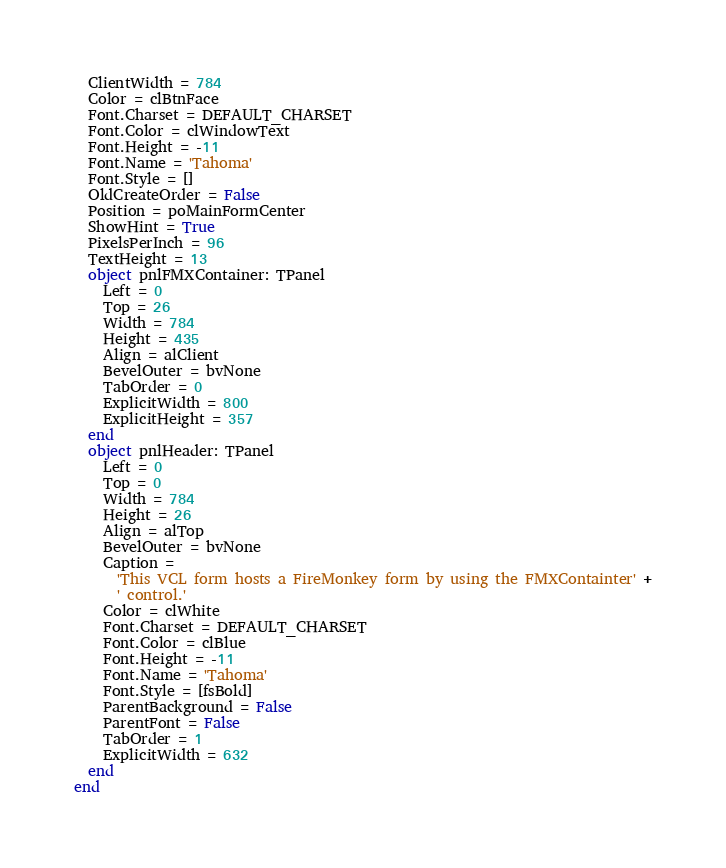<code> <loc_0><loc_0><loc_500><loc_500><_Pascal_>  ClientWidth = 784
  Color = clBtnFace
  Font.Charset = DEFAULT_CHARSET
  Font.Color = clWindowText
  Font.Height = -11
  Font.Name = 'Tahoma'
  Font.Style = []
  OldCreateOrder = False
  Position = poMainFormCenter
  ShowHint = True
  PixelsPerInch = 96
  TextHeight = 13
  object pnlFMXContainer: TPanel
    Left = 0
    Top = 26
    Width = 784
    Height = 435
    Align = alClient
    BevelOuter = bvNone
    TabOrder = 0
    ExplicitWidth = 800
    ExplicitHeight = 357
  end
  object pnlHeader: TPanel
    Left = 0
    Top = 0
    Width = 784
    Height = 26
    Align = alTop
    BevelOuter = bvNone
    Caption = 
      'This VCL form hosts a FireMonkey form by using the FMXContainter' +
      ' control.'
    Color = clWhite
    Font.Charset = DEFAULT_CHARSET
    Font.Color = clBlue
    Font.Height = -11
    Font.Name = 'Tahoma'
    Font.Style = [fsBold]
    ParentBackground = False
    ParentFont = False
    TabOrder = 1
    ExplicitWidth = 632
  end
end
</code> 